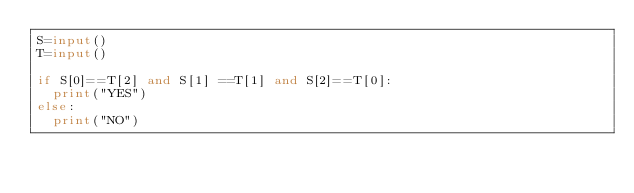Convert code to text. <code><loc_0><loc_0><loc_500><loc_500><_Python_>S=input()
T=input()

if S[0]==T[2] and S[1] ==T[1] and S[2]==T[0]:
  print("YES")
else:
  print("NO")
</code> 